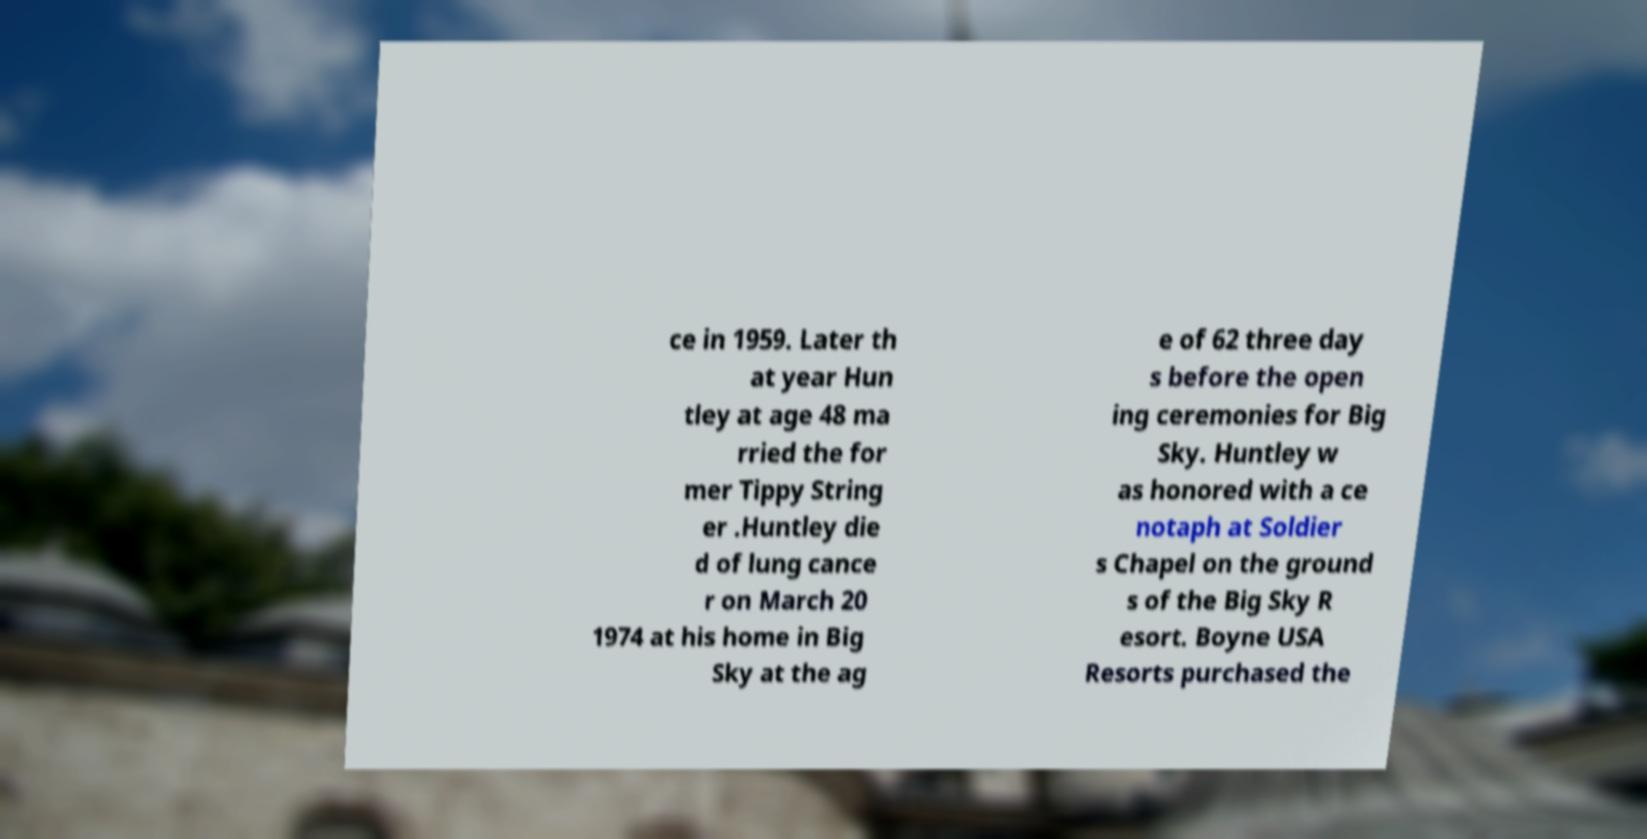Could you assist in decoding the text presented in this image and type it out clearly? ce in 1959. Later th at year Hun tley at age 48 ma rried the for mer Tippy String er .Huntley die d of lung cance r on March 20 1974 at his home in Big Sky at the ag e of 62 three day s before the open ing ceremonies for Big Sky. Huntley w as honored with a ce notaph at Soldier s Chapel on the ground s of the Big Sky R esort. Boyne USA Resorts purchased the 